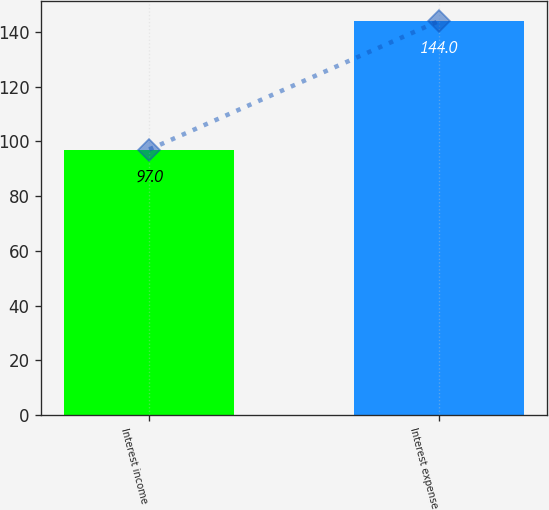<chart> <loc_0><loc_0><loc_500><loc_500><bar_chart><fcel>Interest income<fcel>Interest expense<nl><fcel>97<fcel>144<nl></chart> 